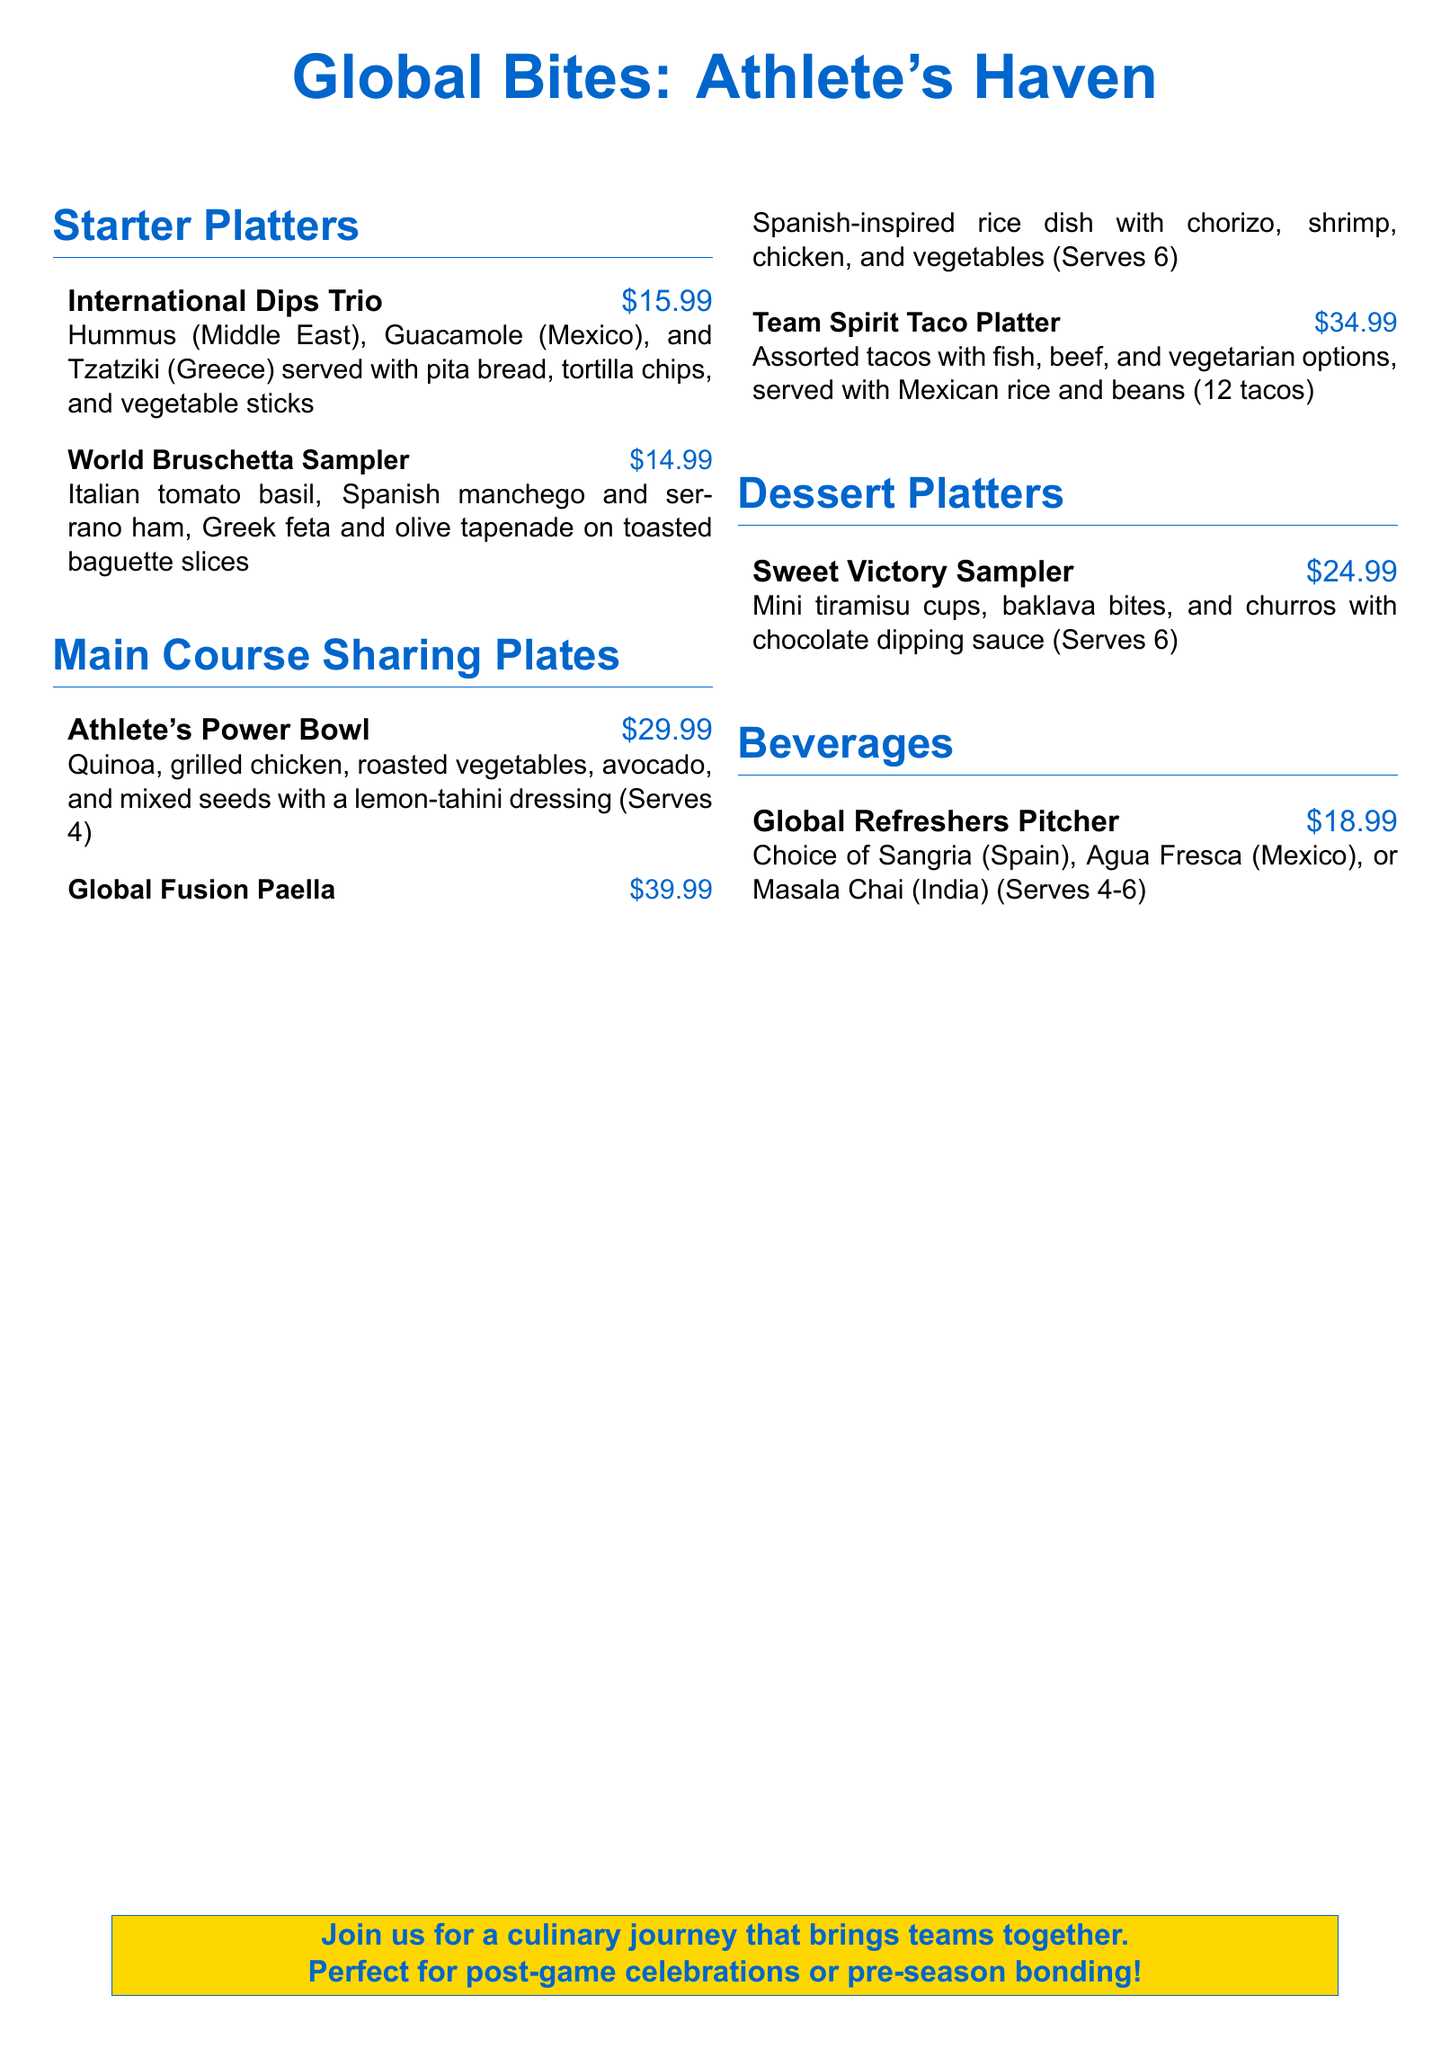What is the title of the menu? The title is presented prominently at the top of the document.
Answer: Global Bites: Athlete's Haven How much does the International Dips Trio cost? The price is specified next to each menu item in the list.
Answer: $15.99 What is included in the Athlete's Power Bowl? The document lists the components of each dish in detail.
Answer: Quinoa, grilled chicken, roasted vegetables, avocado, and mixed seeds How many tacos are served in the Team Spirit Taco Platter? The number of tacos is stated with the menu item details.
Answer: 12 tacos What is the serving size for the Sweet Victory Sampler? The serving size is indicated next to the dessert platter item.
Answer: Serves 6 Which beverage options are available in the Global Refreshers Pitcher? The document lists the specific beverage choices in the item description.
Answer: Sangria, Agua Fresca, Masala Chai What type of cuisine is represented in the World Bruschetta Sampler? The document mentions the cultural origins of each bruschetta type.
Answer: Italian, Spanish, Greek For which occasions is the menu suggested? The concluding statement hints at ideal circumstances for enjoying the menu items.
Answer: Post-game celebrations or pre-season bonding What color is used for the menu title? The title color is specifically defined in the styling of the document.
Answer: Athlete blue 